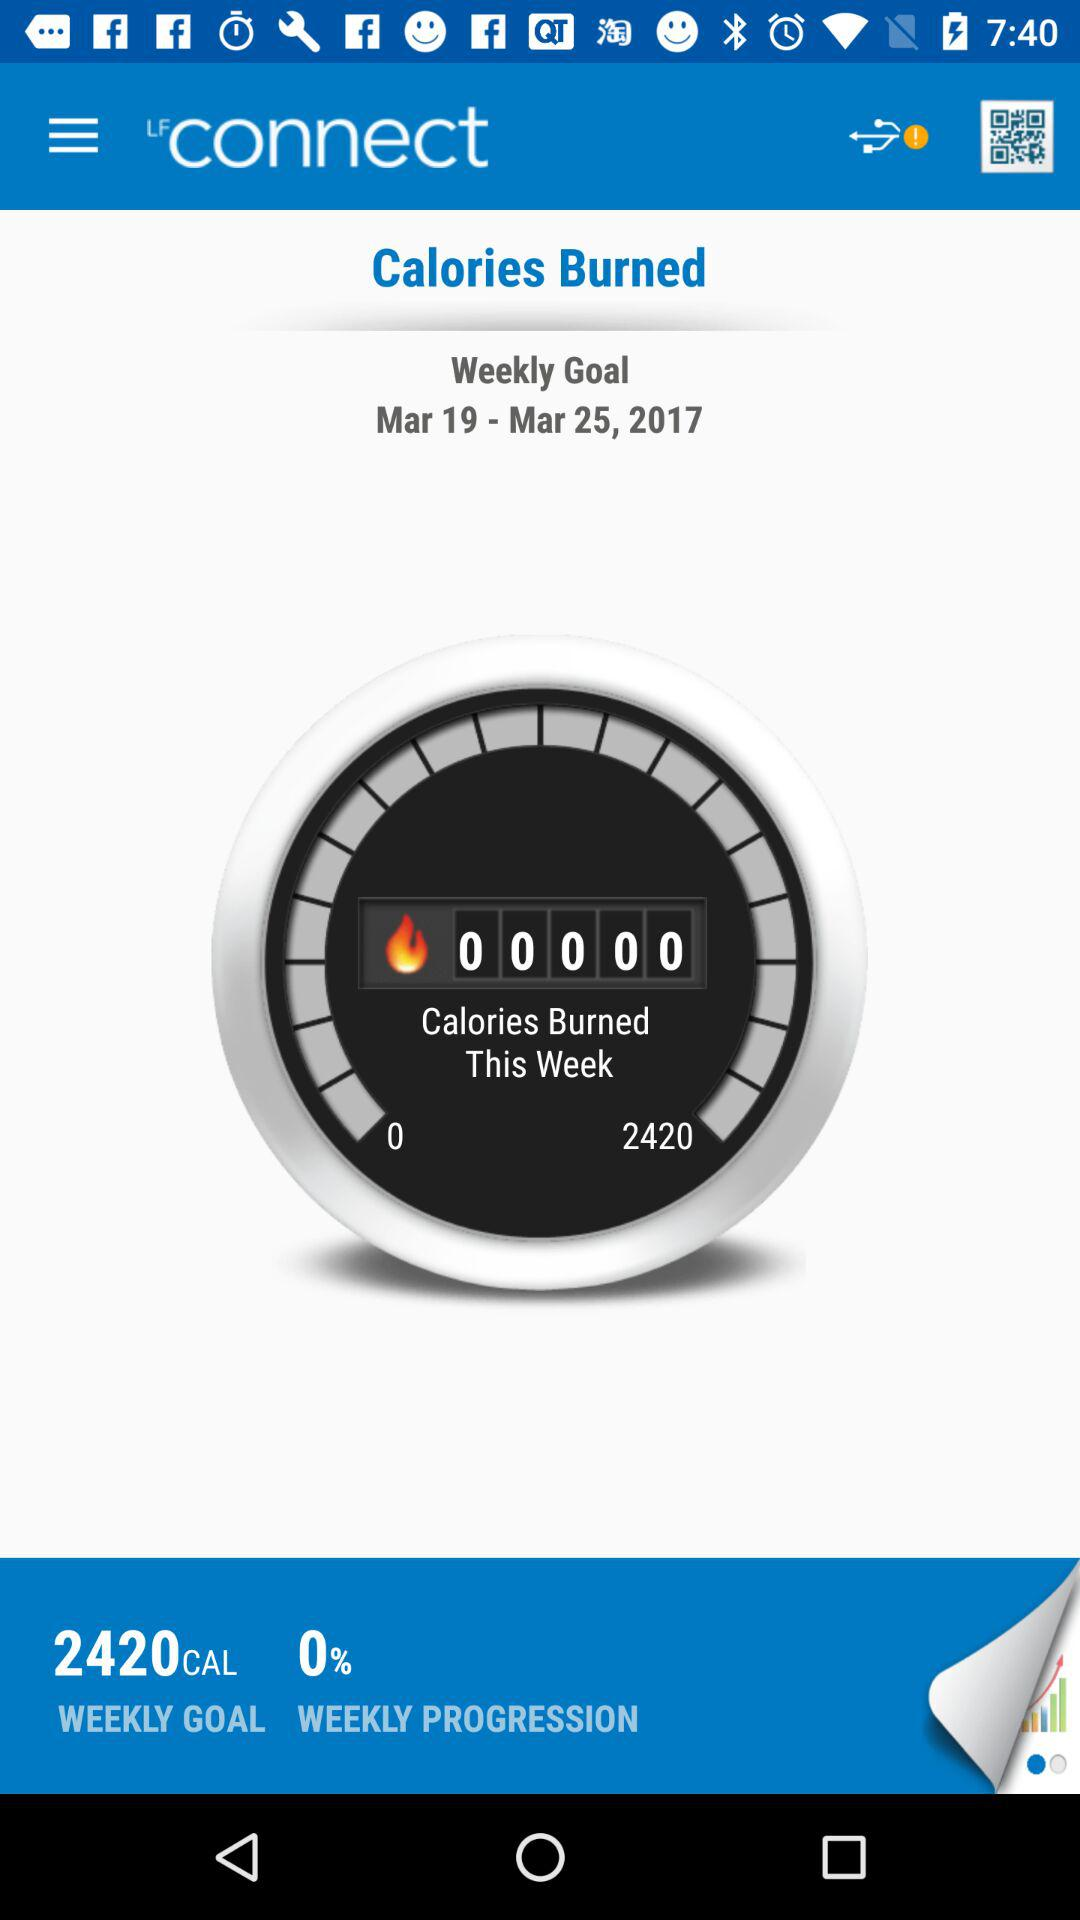How many more calories do I need to burn to reach my weekly goal?
Answer the question using a single word or phrase. 2420 